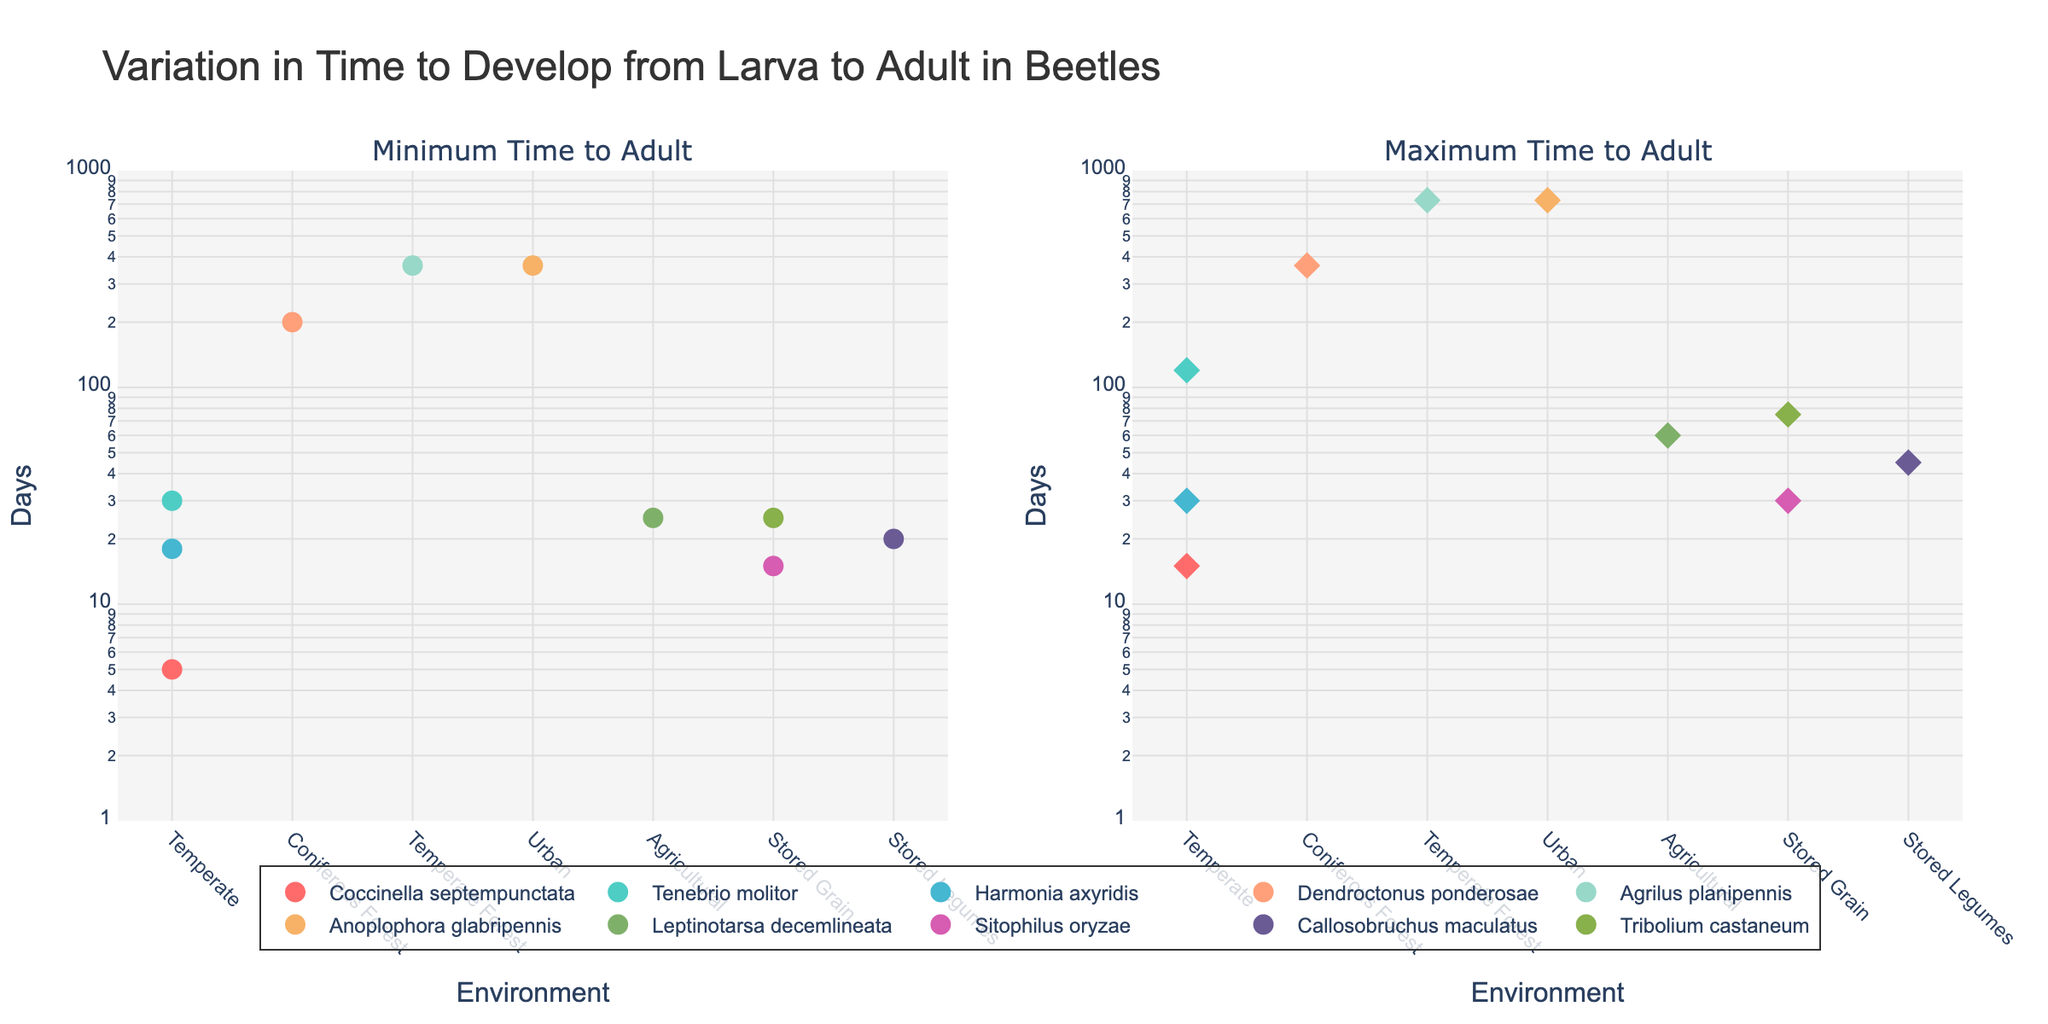What's the title of the figure? The title of the figure is located at the top and reads "Variation in Time to Develop from Larva to Adult in Beetles". This provides an overview of the content depicted in the figure.
Answer: Variation in Time to Develop from Larva to Adult in Beetles How many different environments are shown in the figure? The environments are categories on the x-axis of both subplots. Counting these categories, we see: Temperate, Coniferous Forest, Temperate Forest, Urban, Agricultural, Stored Grain, and Stored Legumes. Therefore, there are 7 unique environments.
Answer: 7 Which species has the shortest minimum time to develop to adult? By looking at the subplot titled "Minimum Time to Adult", we see that "Coccinella septempunctata" has the lowest value on the y-axis, as it is closest to the bottom of the log scale, showing 5 days.
Answer: Coccinella septempunctata What is the range of time for "Tenebrio molitor" to develop into an adult? "Tenebrio molitor" can be found in both subplots. By checking its position, we see its minimum time is 30 days and its maximum time is 120 days. The range is the difference between these two values: 120 - 30 = 90 days.
Answer: 90 days Which species is associated with the longest maximum development time and what environment does it correspond to? In the subplot "Maximum Time to Adult", "Agrilus planipennis" and "Anoplophora glabripennis" both have the highest value on the y-axis at 730 days. Their corresponding environments are Temperate Forest and Urban, respectively.
Answer: "Agrilus planipennis" and "Anoplophora glabripennis" in Temperate Forest and Urban How does the maximum development time of "Dendroctonus ponderosae" compare to "Tenebrio molitor"? "Dendroctonus ponderosae" has a maximum development time of 365 days, whereas "Tenebrio molitor" has a maximum of 120 days. Comparing these, 365 is significantly greater than 120.
Answer: 365 is greater than 120 Are there any species that have an equal minimum and maximum development time? In both subplots, we look for points where the minimum and maximum times coincide. "Agrilus planipennis" and "Anoplophora glabripennis" each show a range from 365 to 730 days, not equal times. No species has matching minimum and maximum development times.
Answer: No What environment has the largest spread in development times within a single species? Checking both subplots for the largest difference within any single species, "Agrilus planipennis" and "Anoplophora glabripennis" both show a spread from 365 to 730 days in Temperate Forest and Urban, giving a spread of 365 days each.
Answer: Temperate Forest and Urban, 365 days Which environments have more than one species listed? Checking the environment categories on the x-axis of both subplots, both "Temperate" and "Stored Grain" display more than one species. Temperate: "Coccinella septempunctata", "Tenebrio molitor", "Harmonia axyridis". Stored Grain: "Sitophilus oryzae", "Tribolium castaneum".
Answer: Temperate, Stored Grain 